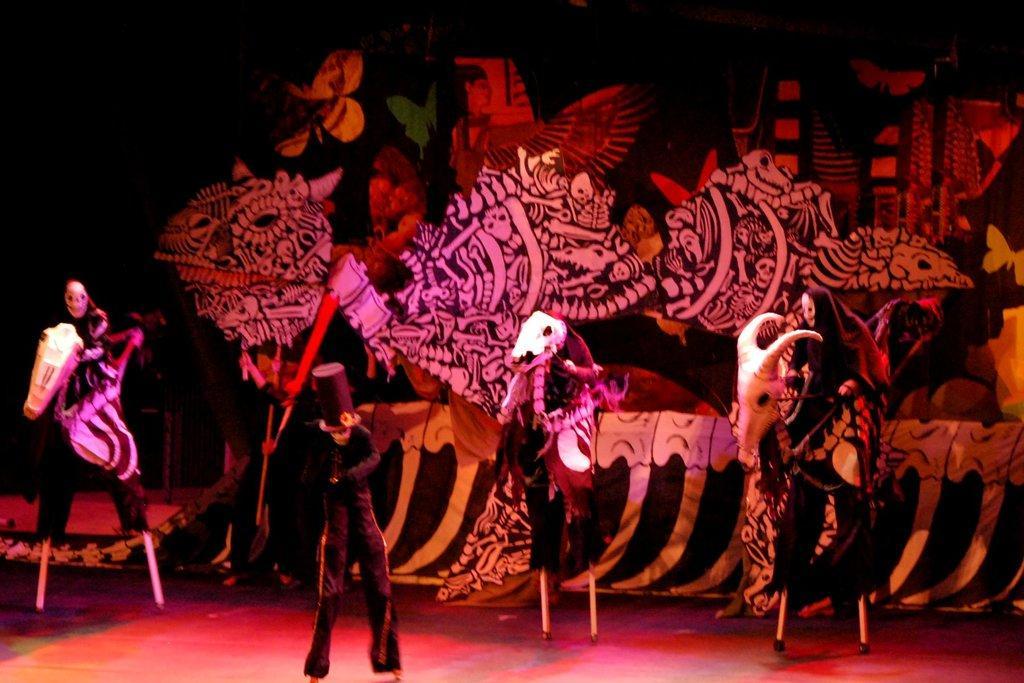Describe this image in one or two sentences. In this image, we can see a person standing, there are some statues and we can see some paintings. 